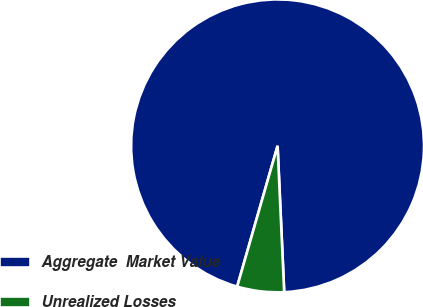Convert chart to OTSL. <chart><loc_0><loc_0><loc_500><loc_500><pie_chart><fcel>Aggregate  Market Value<fcel>Unrealized Losses<nl><fcel>94.83%<fcel>5.17%<nl></chart> 